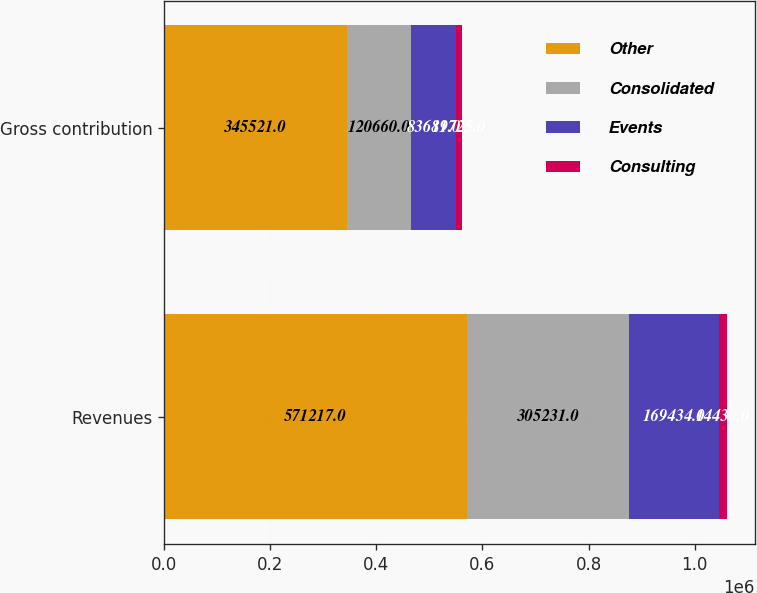Convert chart. <chart><loc_0><loc_0><loc_500><loc_500><stacked_bar_chart><ecel><fcel>Revenues<fcel>Gross contribution<nl><fcel>Other<fcel>571217<fcel>345521<nl><fcel>Consolidated<fcel>305231<fcel>120660<nl><fcel>Events<fcel>169434<fcel>83689<nl><fcel>Consulting<fcel>14439<fcel>11725<nl></chart> 